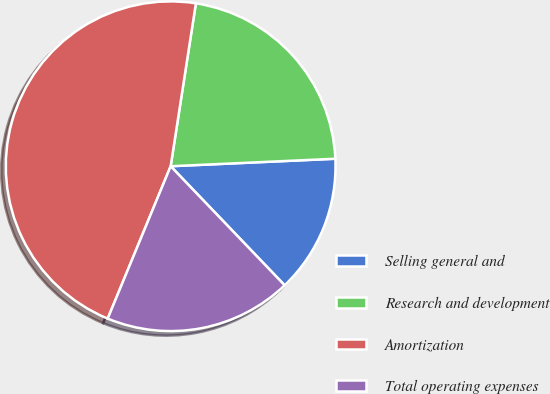<chart> <loc_0><loc_0><loc_500><loc_500><pie_chart><fcel>Selling general and<fcel>Research and development<fcel>Amortization<fcel>Total operating expenses<nl><fcel>13.57%<fcel>21.83%<fcel>46.21%<fcel>18.39%<nl></chart> 